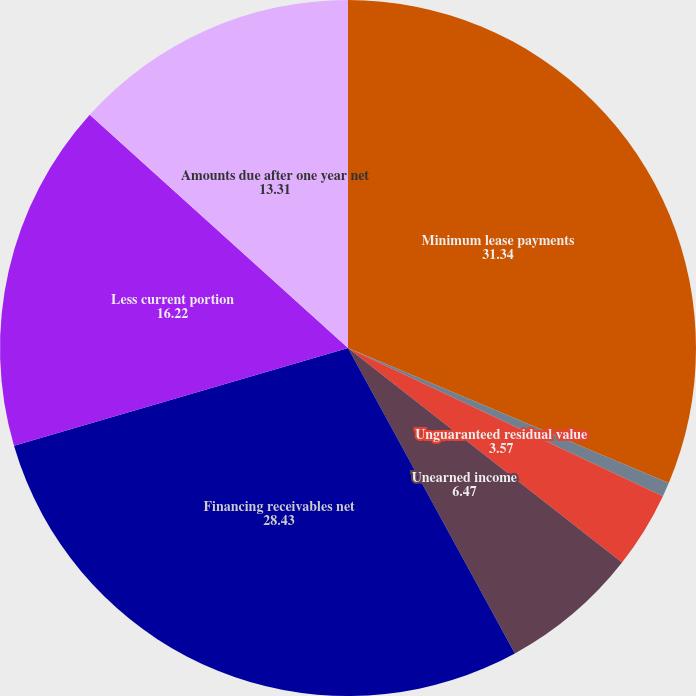<chart> <loc_0><loc_0><loc_500><loc_500><pie_chart><fcel>Minimum lease payments<fcel>Allowance for doubtful<fcel>Unguaranteed residual value<fcel>Unearned income<fcel>Financing receivables net<fcel>Less current portion<fcel>Amounts due after one year net<nl><fcel>31.34%<fcel>0.66%<fcel>3.57%<fcel>6.47%<fcel>28.43%<fcel>16.22%<fcel>13.31%<nl></chart> 